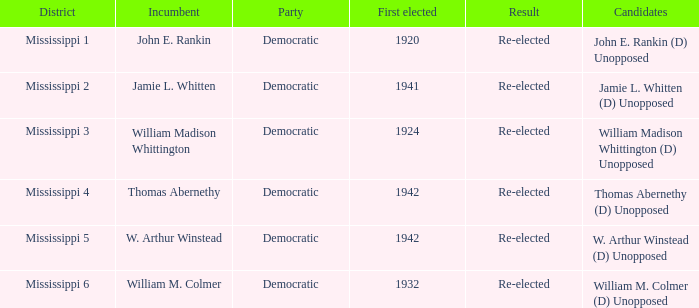What is the consequence for w. arthur winstead? Re-elected. 